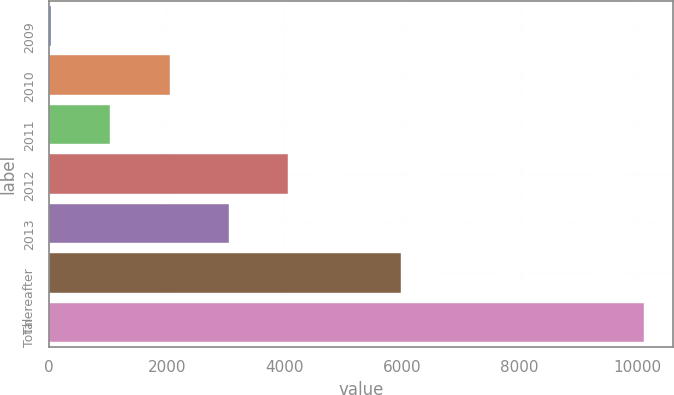Convert chart to OTSL. <chart><loc_0><loc_0><loc_500><loc_500><bar_chart><fcel>2009<fcel>2010<fcel>2011<fcel>2012<fcel>2013<fcel>Thereafter<fcel>Total<nl><fcel>32<fcel>2047.6<fcel>1039.8<fcel>4063.2<fcel>3055.4<fcel>5980<fcel>10110<nl></chart> 